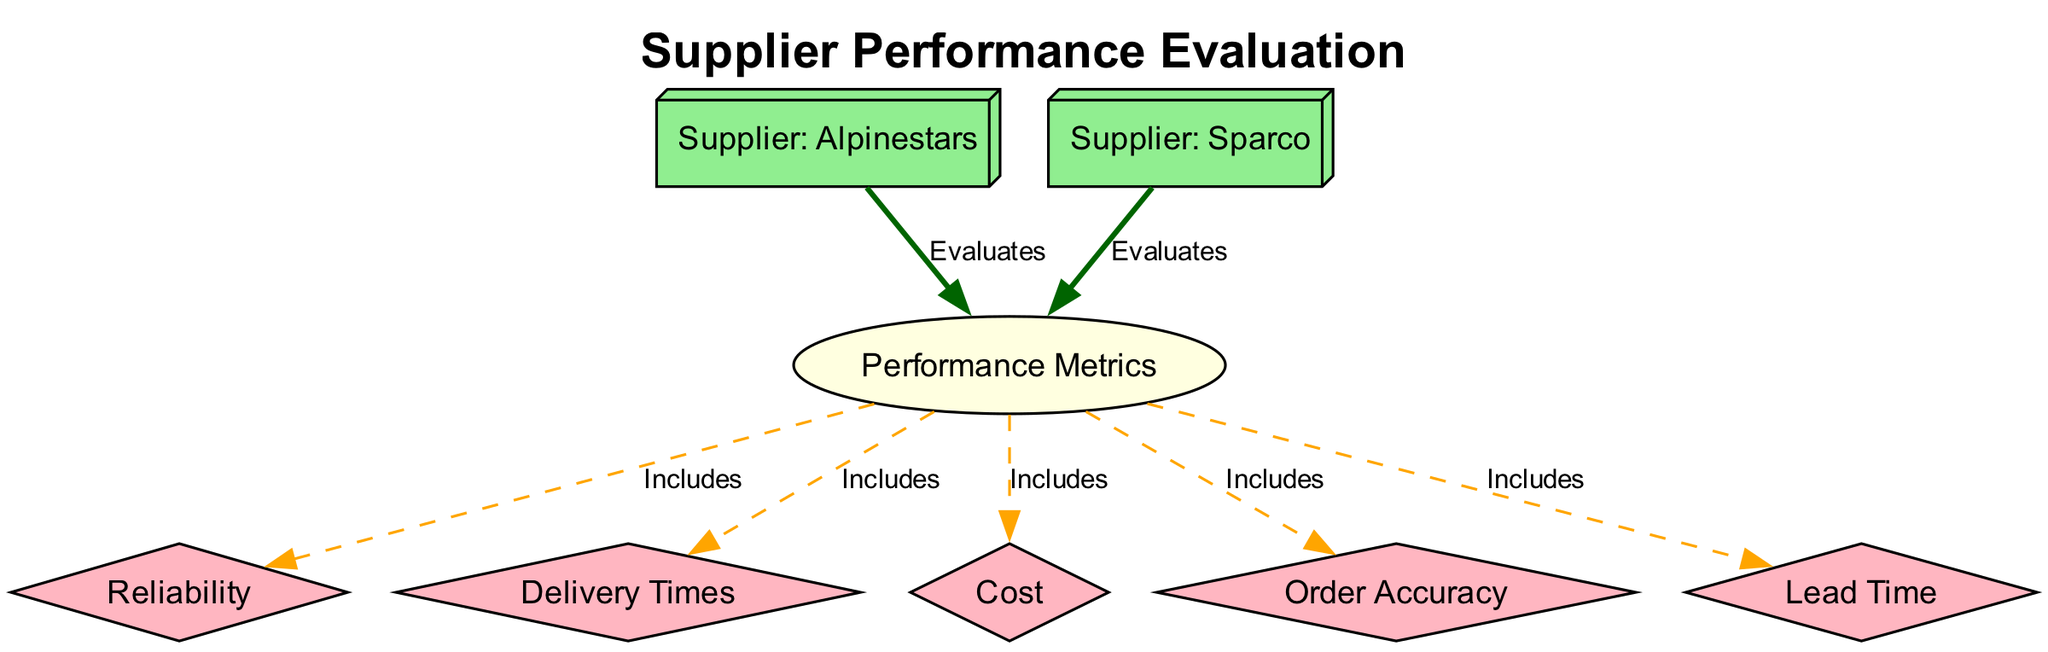What is the title of the diagram? The title of the diagram is found at the top, representing the main focus of the diagram. It is explicitly labeled under the attribute 'title.'
Answer: Supplier Performance Evaluation How many suppliers are evaluated in the diagram? By counting the distinct nodes labeled as suppliers, we identify two specific suppliers present in the diagram: Alpinestars and Sparco.
Answer: 2 What are the performance metrics included in the evaluation? The performance metrics can be identified as the connections stemming from the 'Performance Metrics' node, which lead to reliability, delivery times, cost, order accuracy, and lead time.
Answer: Reliability, Delivery Times, Cost, Order Accuracy, Lead Time Which supplier evaluates the performance metrics? By examining the edges leading to the performance metrics node, we see that both suppliers (Alpinestars and Sparco) evaluate the metrics, meaning they both connect to the performance metrics node.
Answer: Alpinestars, Sparco What type of connection exists between the 'Performance Metrics' node and the 'Reliability' node? The connection between these nodes is indicated as an "Includes" relationship, which specifies the nature of the relationship between performance metrics and reliability.
Answer: Includes Why is the 'Metrics' node shaped as an ellipse? The 'Metrics' node is specifically shaped as an ellipse to differentiate it from other nodes in the diagram, indicating its central role in organizing the metrics evaluation.
Answer: Central Role How are the edges connecting suppliers to metrics differentiated? The edges from the suppliers to the performance metrics are colored dark green and have a pen width of 2, distinguishing them from the dashed orange edges that connect the performance metrics to other metrics.
Answer: Dark Green, Pen Width 2 What does the dashed style of edges from 'Performance Metrics' signify? The dashed style of the edges denotes a specific relationship type that differs from the solid connections from suppliers, indicating that these metrics are characteristics or attributes included in the performance evaluation rather than direct evaluations.
Answer: Characteristics What is one aspect included in the performance metrics? The performance metrics encompass many aspects; one explicit connection is towards 'Lead Time', indicating that it is one of the performance evaluations considered.
Answer: Lead Time 